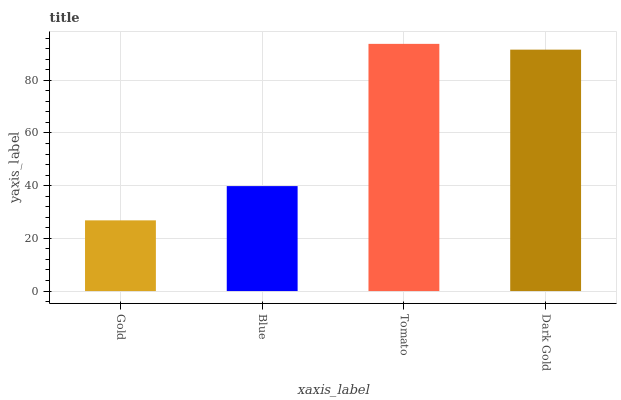Is Gold the minimum?
Answer yes or no. Yes. Is Tomato the maximum?
Answer yes or no. Yes. Is Blue the minimum?
Answer yes or no. No. Is Blue the maximum?
Answer yes or no. No. Is Blue greater than Gold?
Answer yes or no. Yes. Is Gold less than Blue?
Answer yes or no. Yes. Is Gold greater than Blue?
Answer yes or no. No. Is Blue less than Gold?
Answer yes or no. No. Is Dark Gold the high median?
Answer yes or no. Yes. Is Blue the low median?
Answer yes or no. Yes. Is Blue the high median?
Answer yes or no. No. Is Dark Gold the low median?
Answer yes or no. No. 